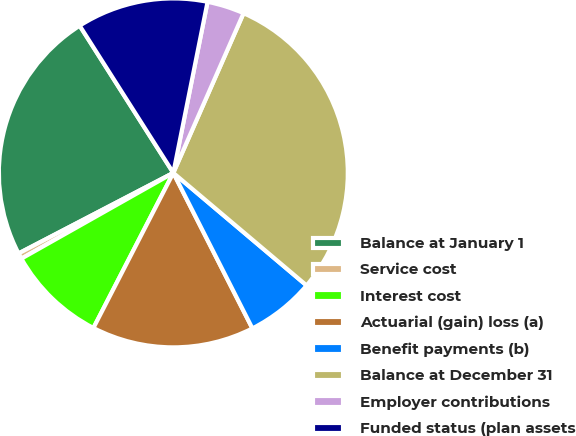Convert chart. <chart><loc_0><loc_0><loc_500><loc_500><pie_chart><fcel>Balance at January 1<fcel>Service cost<fcel>Interest cost<fcel>Actuarial (gain) loss (a)<fcel>Benefit payments (b)<fcel>Balance at December 31<fcel>Employer contributions<fcel>Funded status (plan assets<nl><fcel>23.62%<fcel>0.54%<fcel>9.25%<fcel>15.06%<fcel>6.35%<fcel>29.57%<fcel>3.45%<fcel>12.16%<nl></chart> 